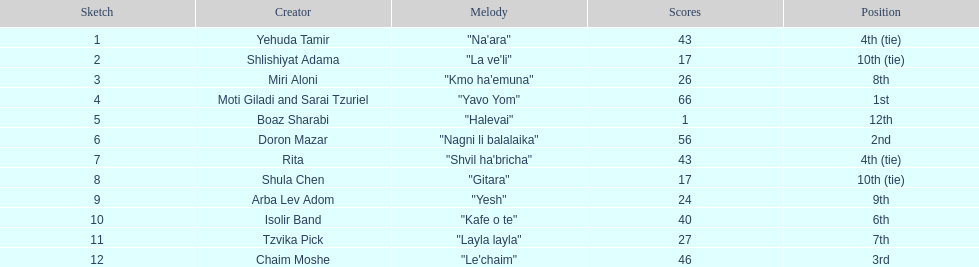What is the name of the first song listed on this chart? "Na'ara". 